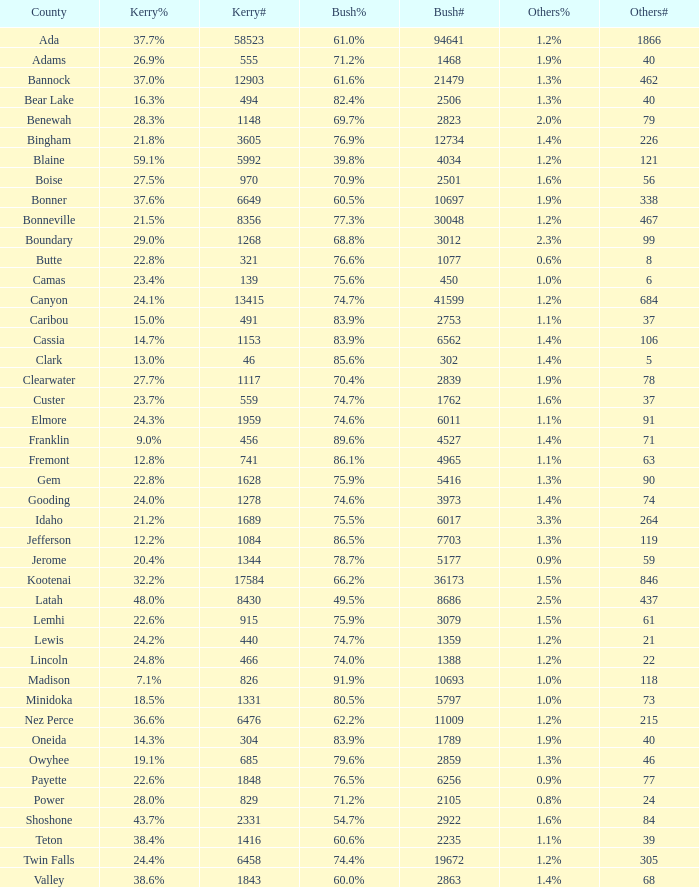What percentage of the people in Bonneville voted for Bush? 77.3%. 